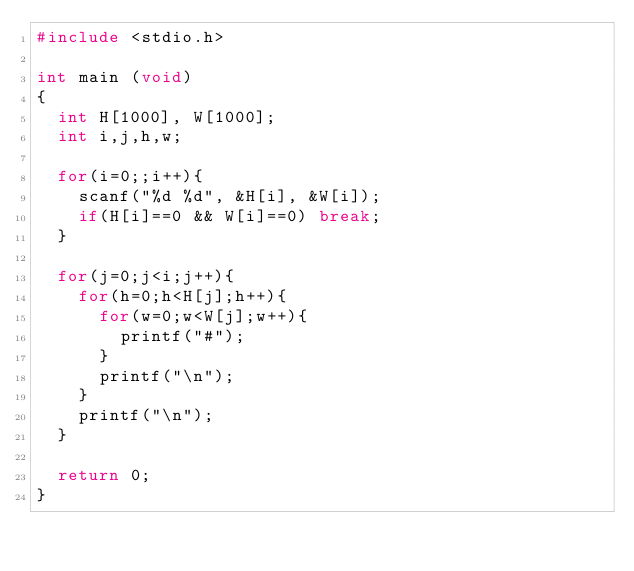Convert code to text. <code><loc_0><loc_0><loc_500><loc_500><_C_>#include <stdio.h>

int main (void)
{
	int H[1000], W[1000];
	int i,j,h,w;

	for(i=0;;i++){
		scanf("%d %d", &H[i], &W[i]);
		if(H[i]==0 && W[i]==0) break;
	}

	for(j=0;j<i;j++){
		for(h=0;h<H[j];h++){
			for(w=0;w<W[j];w++){
				printf("#");
			}
			printf("\n");
		}
		printf("\n");
	}

	return 0;
}</code> 